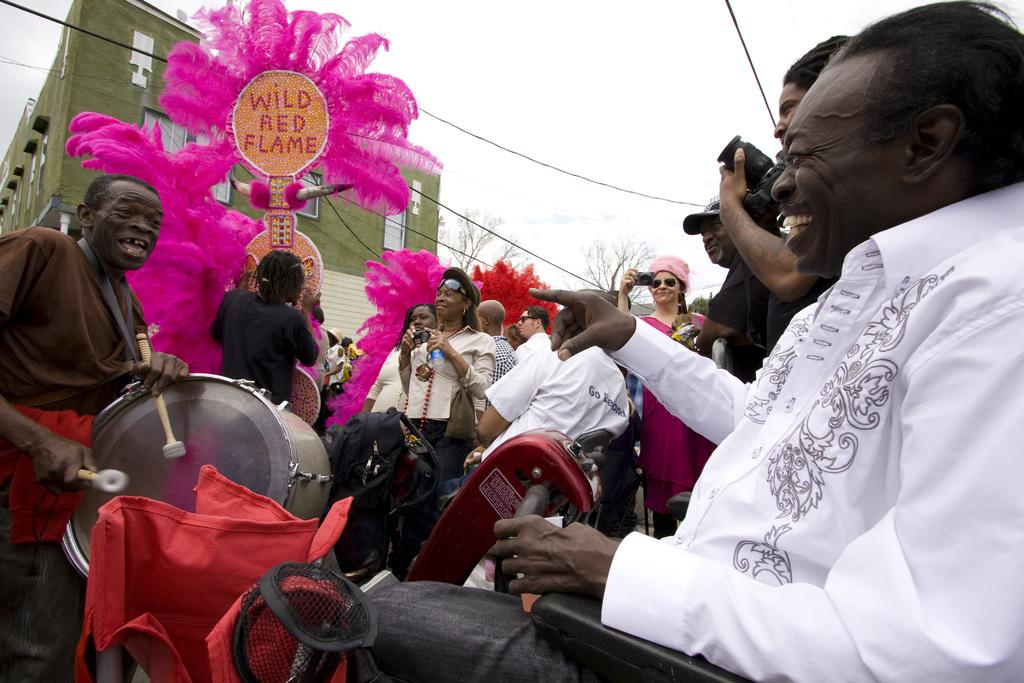What is the man in the image doing? The man is sitting in an automated vehicle. What is happening in front of the vehicle? There is another man playing drums in front of the vehicle. Are there any other people in the image? Yes, there are people around the vehicle and the drum player. What can be seen in the background of the image? There is a building in the background of the image. How would you describe the weather based on the image? The sky is cloudy in the image. What type of doctor is examining the clock in the image? There is no doctor or clock present in the image. Can you tell me how many people are swimming in the image? There is no swimming or pool visible in the image. 